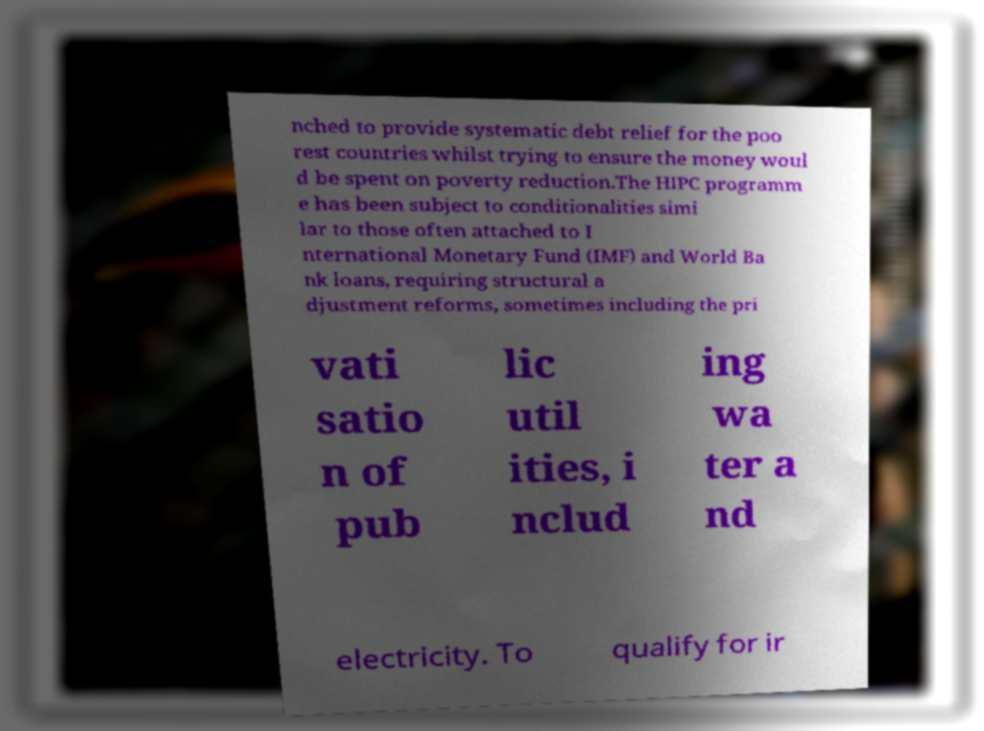Can you read and provide the text displayed in the image?This photo seems to have some interesting text. Can you extract and type it out for me? nched to provide systematic debt relief for the poo rest countries whilst trying to ensure the money woul d be spent on poverty reduction.The HIPC programm e has been subject to conditionalities simi lar to those often attached to I nternational Monetary Fund (IMF) and World Ba nk loans, requiring structural a djustment reforms, sometimes including the pri vati satio n of pub lic util ities, i nclud ing wa ter a nd electricity. To qualify for ir 